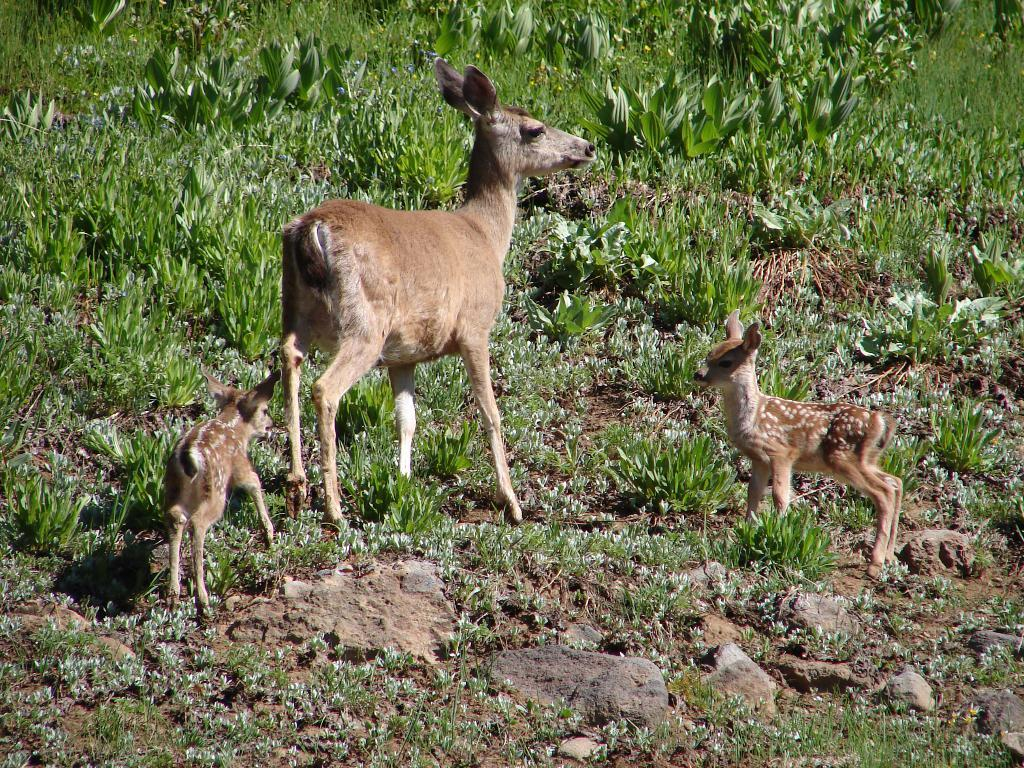What animal is located in the middle of the image? There is a deer in the middle of the image. What other animals can be seen on either side of the image? There are two calves on either side of the image. What type of vegetation is visible at the top of the image? There are plants visible at the top of the image. How many cakes are being kicked by the deer in the image? There are no cakes or kicking actions present in the image. 